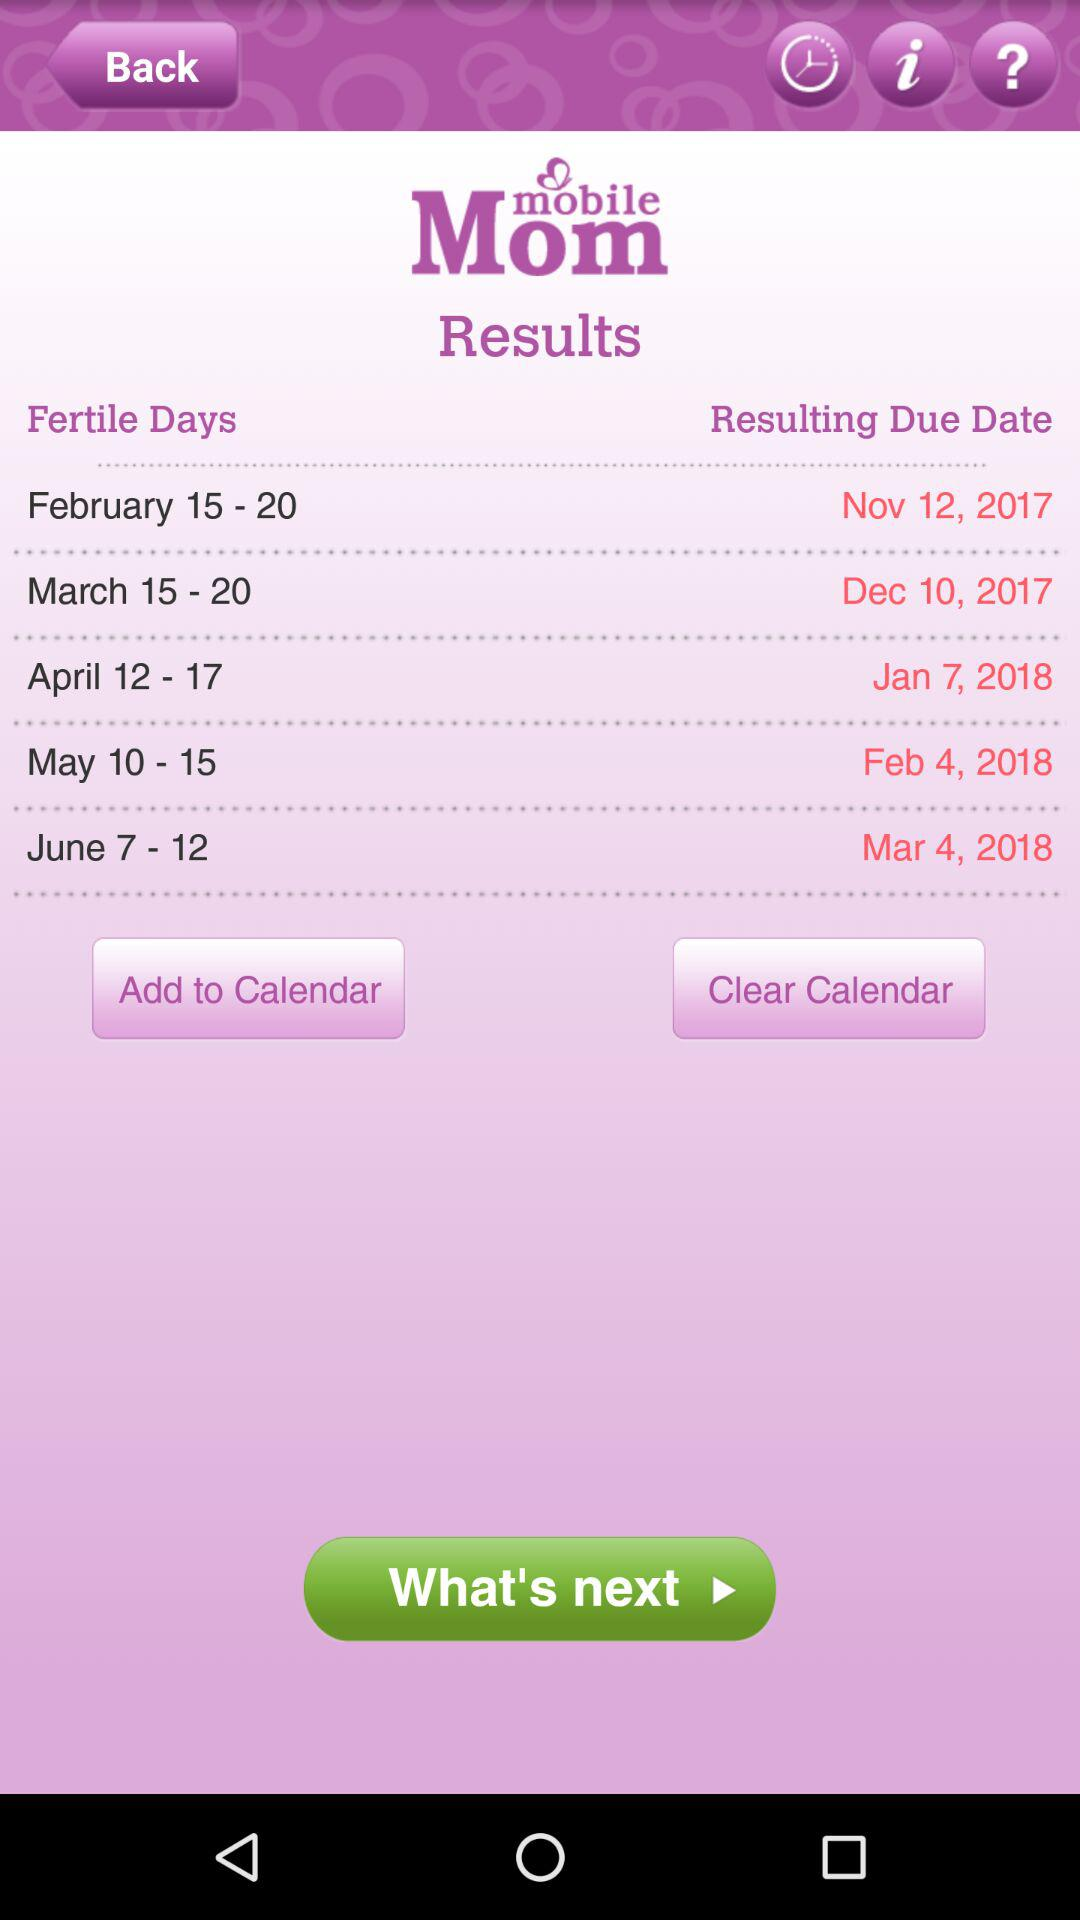When is the fertile day that will result in the March 4, 2018 due date? The fertile days that will result in the March 4, 2018 due date are from June 7 to June 12. 